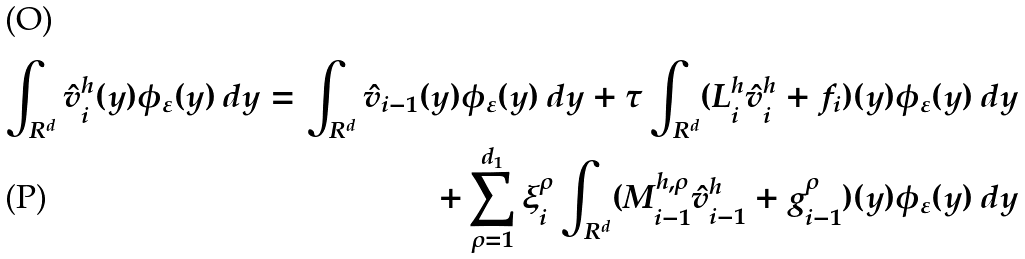<formula> <loc_0><loc_0><loc_500><loc_500>\int _ { R ^ { d } } \hat { v } ^ { h } _ { i } ( y ) \phi _ { \varepsilon } ( y ) \, d y = \int _ { R ^ { d } } \hat { v } _ { i - 1 } ( y ) \phi _ { \varepsilon } ( y ) \, d y + \tau \int _ { R ^ { d } } ( L ^ { h } _ { i } \hat { v } ^ { h } _ { i } + f _ { i } ) ( y ) \phi _ { \varepsilon } ( y ) \, d y \\ + \sum _ { \rho = 1 } ^ { d _ { 1 } } \xi ^ { \rho } _ { i } \int _ { R ^ { d } } ( M ^ { h , \rho } _ { i - 1 } \hat { v } ^ { h } _ { i - 1 } + g ^ { \rho } _ { i - 1 } ) ( y ) \phi _ { \varepsilon } ( y ) \, d y</formula> 